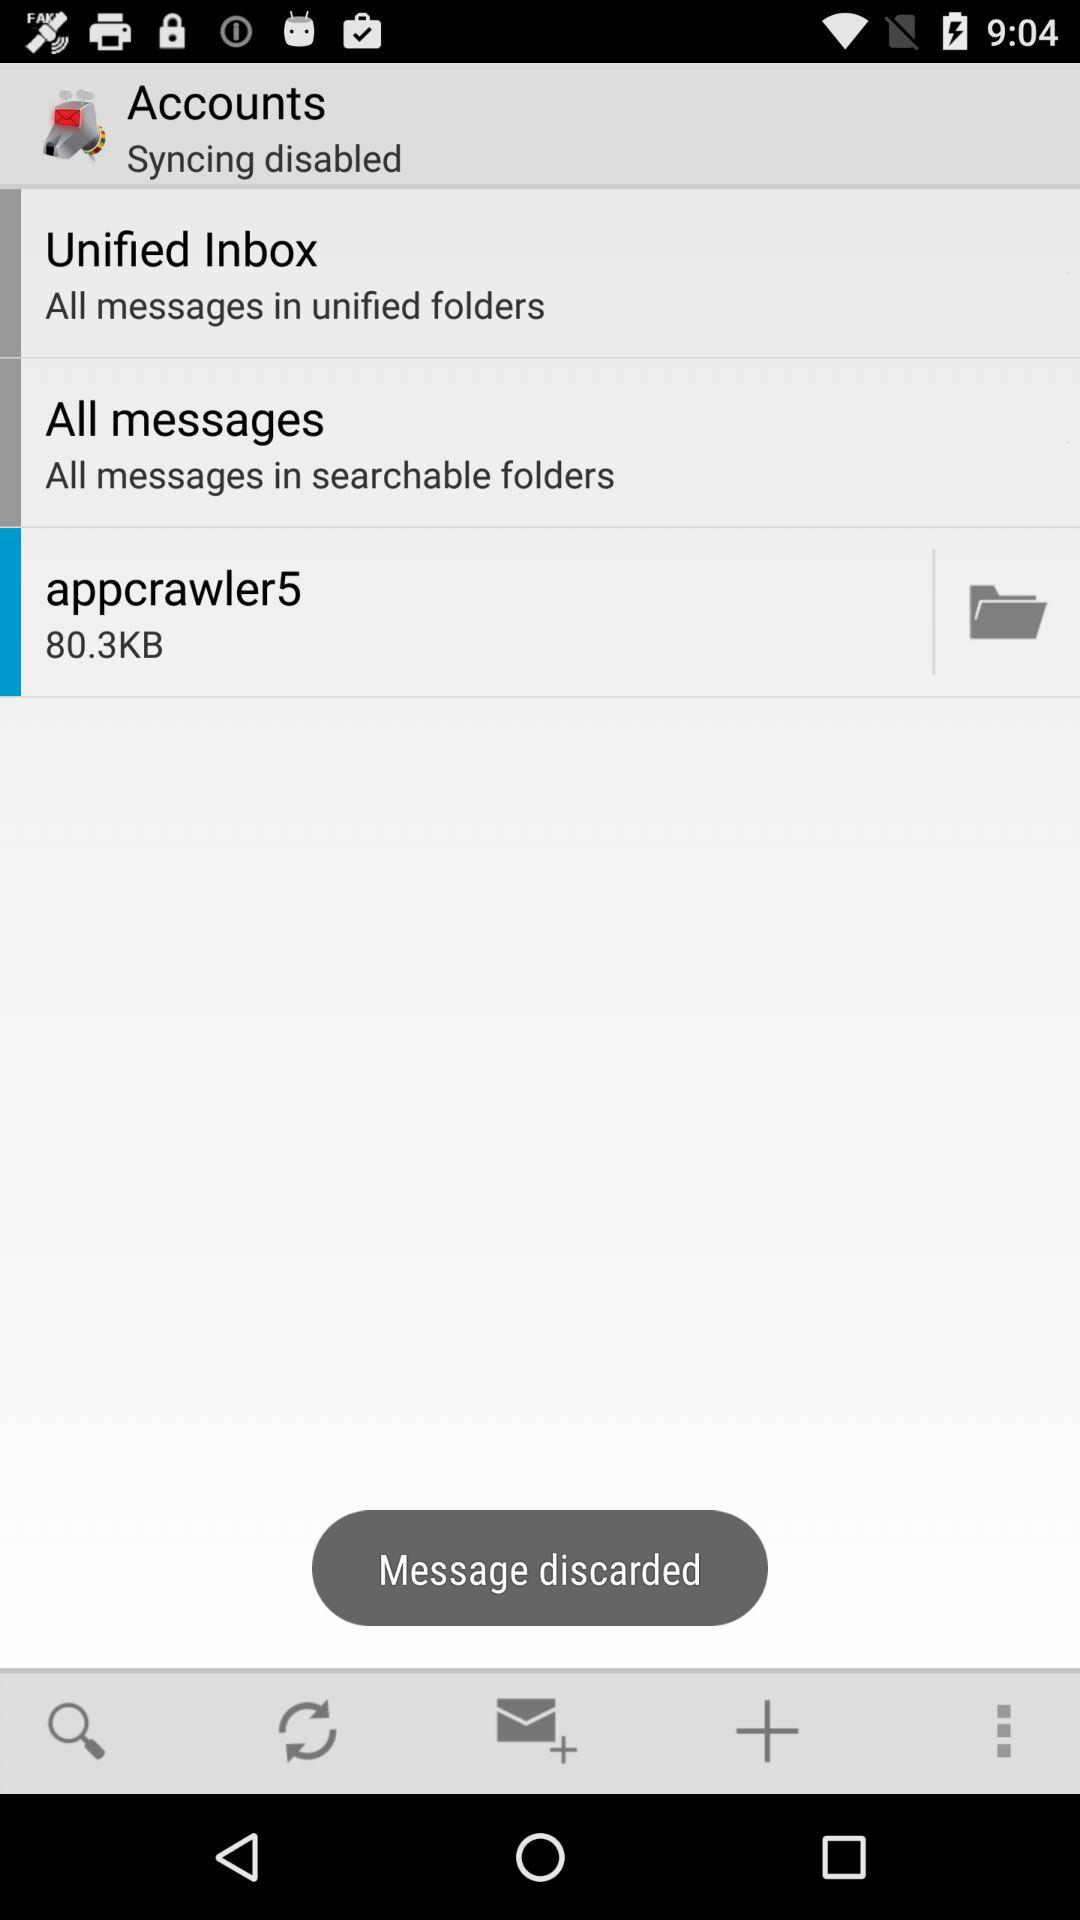How many messages are there?
When the provided information is insufficient, respond with <no answer>. <no answer> 